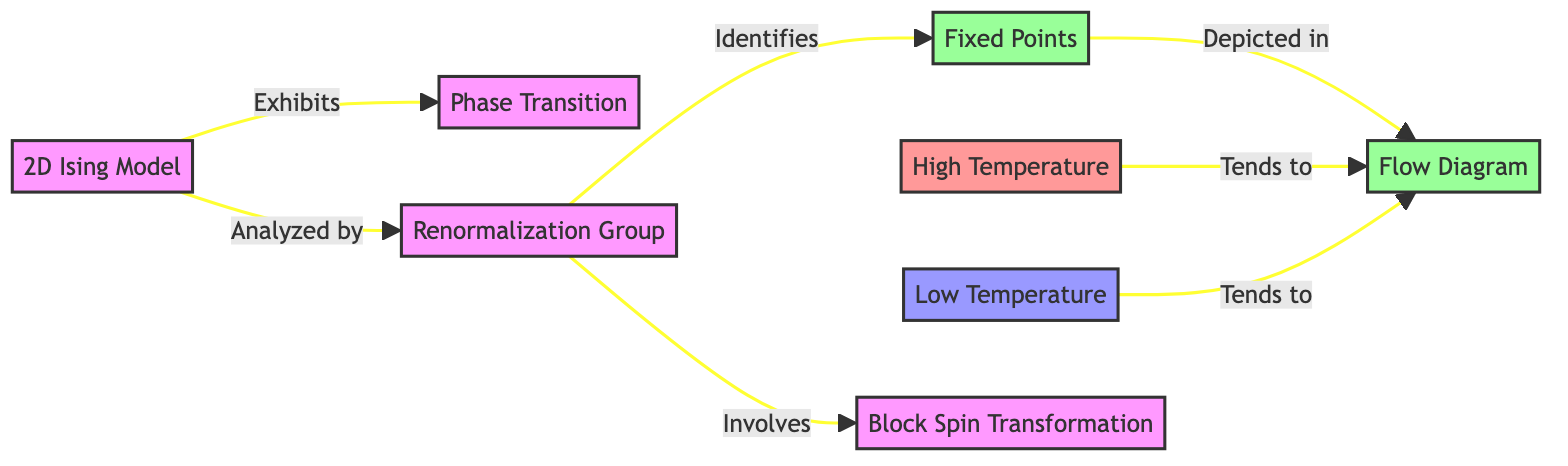What does the 2D Ising Model exhibit? The diagram states that the 2D Ising Model exhibits a Phase Transition, which is specifically mentioned as one of the relationships depicted in the diagram.
Answer: Phase Transition What is the role of the Renormalization Group in the diagram? According to the flowchart, the Renormalization Group analyzes the 2D Ising Model and identifies Fixed Points, making it a critical component in understanding the model's behavior.
Answer: Analyzed by How many fixed points are identified in the diagram? The diagram indicates one Fixed Point node but does not explicitly state a number. However, the diagram connects Renormalization Group to Fixed Points, suggesting a singular conceptual representation in this context.
Answer: 1 What happens to the high temperature in relation to the fixed points? The diagram shows an arrow pointing from High Temperature to the Fixed Point, indicating that High Temperature conditions tend to flow towards a specific outcome at the Fixed Point.
Answer: Tends to What is involved in the Renormalization Group analysis? The diagram explicitly lists Block Spin Transformation as a component involved in the Renormalization Group analysis. This indicates a method used to study the system's properties.
Answer: Block Spin Transformation What type of diagram is depicted for the Fixed Points? The flowchart indicates that Fixed Points are depicted in a Flow Diagram, highlighting the method of representation used for these important concepts within the analysis.
Answer: Flow Diagram How do low temperatures relate to fixed points in the diagram? The diagram shows that Low Temperature also flows toward the Fixed Point, which suggests a convergence in behavior across varying temperature conditions leading to these Fixed Points.
Answer: Tends to What color represents the high-temperature state? The flowchart distinguishes the High Temperature state with a pinkish color (fill: #ff9999), making it visually recognizable within the diagram's design.
Answer: Pink 